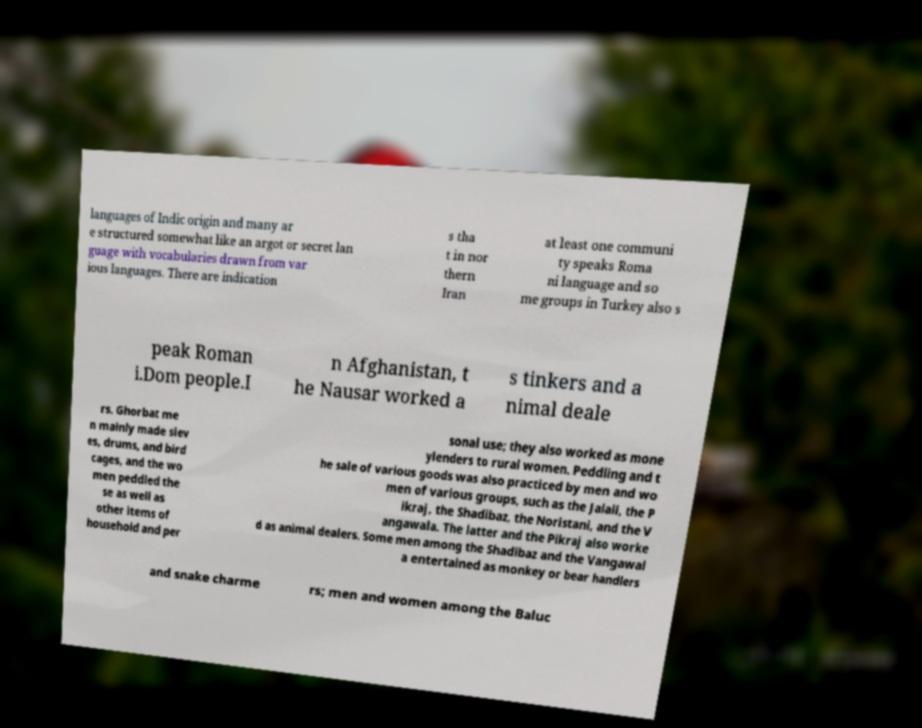Can you accurately transcribe the text from the provided image for me? languages of Indic origin and many ar e structured somewhat like an argot or secret lan guage with vocabularies drawn from var ious languages. There are indication s tha t in nor thern Iran at least one communi ty speaks Roma ni language and so me groups in Turkey also s peak Roman i.Dom people.I n Afghanistan, t he Nausar worked a s tinkers and a nimal deale rs. Ghorbat me n mainly made siev es, drums, and bird cages, and the wo men peddled the se as well as other items of household and per sonal use; they also worked as mone ylenders to rural women. Peddling and t he sale of various goods was also practiced by men and wo men of various groups, such as the Jalali, the P ikraj, the Shadibaz, the Noristani, and the V angawala. The latter and the Pikraj also worke d as animal dealers. Some men among the Shadibaz and the Vangawal a entertained as monkey or bear handlers and snake charme rs; men and women among the Baluc 